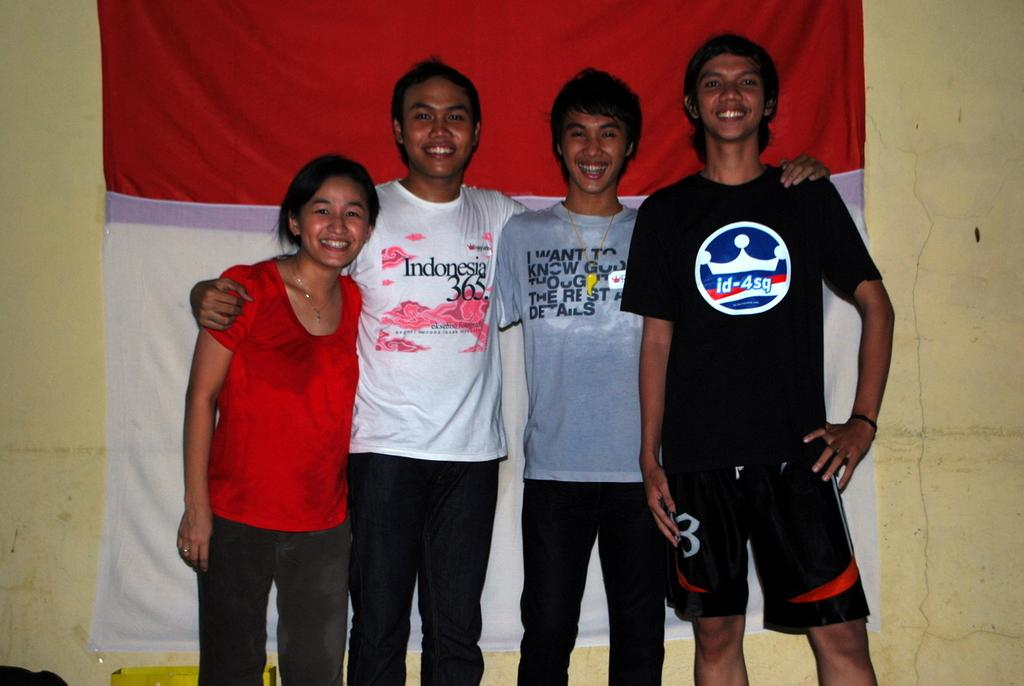<image>
Offer a succinct explanation of the picture presented. Four people from Indonesia smiling and posing in front of a flag. 